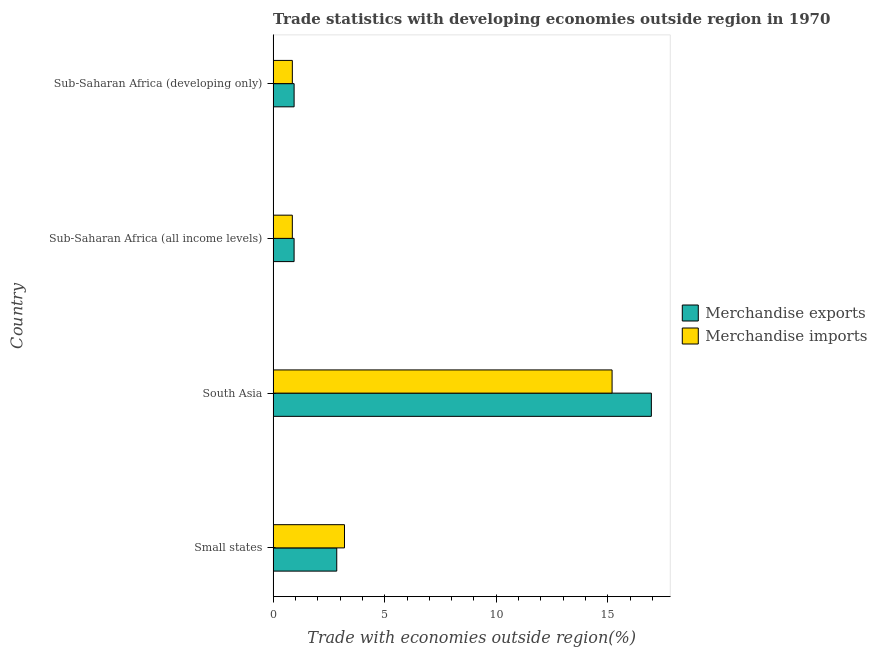How many different coloured bars are there?
Your answer should be compact. 2. Are the number of bars per tick equal to the number of legend labels?
Your answer should be very brief. Yes. How many bars are there on the 2nd tick from the bottom?
Your response must be concise. 2. What is the label of the 3rd group of bars from the top?
Your response must be concise. South Asia. In how many cases, is the number of bars for a given country not equal to the number of legend labels?
Provide a succinct answer. 0. What is the merchandise imports in South Asia?
Your response must be concise. 15.19. Across all countries, what is the maximum merchandise imports?
Provide a short and direct response. 15.19. Across all countries, what is the minimum merchandise exports?
Make the answer very short. 0.94. In which country was the merchandise imports minimum?
Your answer should be compact. Sub-Saharan Africa (all income levels). What is the total merchandise exports in the graph?
Make the answer very short. 21.68. What is the difference between the merchandise imports in Sub-Saharan Africa (all income levels) and that in Sub-Saharan Africa (developing only)?
Your answer should be compact. -0. What is the difference between the merchandise exports in South Asia and the merchandise imports in Sub-Saharan Africa (developing only)?
Ensure brevity in your answer.  16.09. What is the average merchandise imports per country?
Make the answer very short. 5.03. What is the difference between the merchandise exports and merchandise imports in Sub-Saharan Africa (developing only)?
Your answer should be compact. 0.08. In how many countries, is the merchandise exports greater than 9 %?
Offer a very short reply. 1. What is the ratio of the merchandise imports in Small states to that in South Asia?
Provide a short and direct response. 0.21. Is the merchandise exports in Small states less than that in Sub-Saharan Africa (developing only)?
Your response must be concise. No. Is the difference between the merchandise exports in Small states and Sub-Saharan Africa (all income levels) greater than the difference between the merchandise imports in Small states and Sub-Saharan Africa (all income levels)?
Offer a very short reply. No. What is the difference between the highest and the second highest merchandise imports?
Your answer should be compact. 11.99. What is the difference between the highest and the lowest merchandise imports?
Your answer should be compact. 14.33. Is the sum of the merchandise imports in Small states and South Asia greater than the maximum merchandise exports across all countries?
Your answer should be very brief. Yes. How many bars are there?
Your answer should be compact. 8. Are all the bars in the graph horizontal?
Offer a very short reply. Yes. How many countries are there in the graph?
Your response must be concise. 4. Does the graph contain any zero values?
Ensure brevity in your answer.  No. Does the graph contain grids?
Offer a very short reply. No. Where does the legend appear in the graph?
Your response must be concise. Center right. How many legend labels are there?
Provide a succinct answer. 2. What is the title of the graph?
Offer a terse response. Trade statistics with developing economies outside region in 1970. What is the label or title of the X-axis?
Your response must be concise. Trade with economies outside region(%). What is the label or title of the Y-axis?
Offer a terse response. Country. What is the Trade with economies outside region(%) of Merchandise exports in Small states?
Provide a succinct answer. 2.85. What is the Trade with economies outside region(%) of Merchandise imports in Small states?
Give a very brief answer. 3.2. What is the Trade with economies outside region(%) in Merchandise exports in South Asia?
Your answer should be compact. 16.95. What is the Trade with economies outside region(%) of Merchandise imports in South Asia?
Ensure brevity in your answer.  15.19. What is the Trade with economies outside region(%) of Merchandise exports in Sub-Saharan Africa (all income levels)?
Ensure brevity in your answer.  0.94. What is the Trade with economies outside region(%) of Merchandise imports in Sub-Saharan Africa (all income levels)?
Give a very brief answer. 0.86. What is the Trade with economies outside region(%) of Merchandise exports in Sub-Saharan Africa (developing only)?
Provide a succinct answer. 0.94. What is the Trade with economies outside region(%) in Merchandise imports in Sub-Saharan Africa (developing only)?
Keep it short and to the point. 0.86. Across all countries, what is the maximum Trade with economies outside region(%) in Merchandise exports?
Offer a terse response. 16.95. Across all countries, what is the maximum Trade with economies outside region(%) in Merchandise imports?
Give a very brief answer. 15.19. Across all countries, what is the minimum Trade with economies outside region(%) of Merchandise exports?
Ensure brevity in your answer.  0.94. Across all countries, what is the minimum Trade with economies outside region(%) in Merchandise imports?
Provide a succinct answer. 0.86. What is the total Trade with economies outside region(%) in Merchandise exports in the graph?
Keep it short and to the point. 21.68. What is the total Trade with economies outside region(%) in Merchandise imports in the graph?
Ensure brevity in your answer.  20.11. What is the difference between the Trade with economies outside region(%) of Merchandise exports in Small states and that in South Asia?
Give a very brief answer. -14.1. What is the difference between the Trade with economies outside region(%) in Merchandise imports in Small states and that in South Asia?
Your answer should be compact. -11.99. What is the difference between the Trade with economies outside region(%) in Merchandise exports in Small states and that in Sub-Saharan Africa (all income levels)?
Provide a short and direct response. 1.91. What is the difference between the Trade with economies outside region(%) in Merchandise imports in Small states and that in Sub-Saharan Africa (all income levels)?
Offer a terse response. 2.34. What is the difference between the Trade with economies outside region(%) of Merchandise exports in Small states and that in Sub-Saharan Africa (developing only)?
Provide a short and direct response. 1.91. What is the difference between the Trade with economies outside region(%) in Merchandise imports in Small states and that in Sub-Saharan Africa (developing only)?
Provide a short and direct response. 2.34. What is the difference between the Trade with economies outside region(%) of Merchandise exports in South Asia and that in Sub-Saharan Africa (all income levels)?
Provide a short and direct response. 16.01. What is the difference between the Trade with economies outside region(%) of Merchandise imports in South Asia and that in Sub-Saharan Africa (all income levels)?
Make the answer very short. 14.33. What is the difference between the Trade with economies outside region(%) of Merchandise exports in South Asia and that in Sub-Saharan Africa (developing only)?
Offer a terse response. 16.01. What is the difference between the Trade with economies outside region(%) in Merchandise imports in South Asia and that in Sub-Saharan Africa (developing only)?
Your answer should be very brief. 14.33. What is the difference between the Trade with economies outside region(%) in Merchandise exports in Sub-Saharan Africa (all income levels) and that in Sub-Saharan Africa (developing only)?
Your answer should be very brief. -0. What is the difference between the Trade with economies outside region(%) in Merchandise imports in Sub-Saharan Africa (all income levels) and that in Sub-Saharan Africa (developing only)?
Provide a short and direct response. -0. What is the difference between the Trade with economies outside region(%) in Merchandise exports in Small states and the Trade with economies outside region(%) in Merchandise imports in South Asia?
Keep it short and to the point. -12.34. What is the difference between the Trade with economies outside region(%) of Merchandise exports in Small states and the Trade with economies outside region(%) of Merchandise imports in Sub-Saharan Africa (all income levels)?
Offer a very short reply. 1.99. What is the difference between the Trade with economies outside region(%) of Merchandise exports in Small states and the Trade with economies outside region(%) of Merchandise imports in Sub-Saharan Africa (developing only)?
Your answer should be very brief. 1.99. What is the difference between the Trade with economies outside region(%) of Merchandise exports in South Asia and the Trade with economies outside region(%) of Merchandise imports in Sub-Saharan Africa (all income levels)?
Your answer should be very brief. 16.09. What is the difference between the Trade with economies outside region(%) of Merchandise exports in South Asia and the Trade with economies outside region(%) of Merchandise imports in Sub-Saharan Africa (developing only)?
Offer a very short reply. 16.09. What is the difference between the Trade with economies outside region(%) in Merchandise exports in Sub-Saharan Africa (all income levels) and the Trade with economies outside region(%) in Merchandise imports in Sub-Saharan Africa (developing only)?
Provide a succinct answer. 0.08. What is the average Trade with economies outside region(%) in Merchandise exports per country?
Your answer should be very brief. 5.42. What is the average Trade with economies outside region(%) of Merchandise imports per country?
Offer a very short reply. 5.03. What is the difference between the Trade with economies outside region(%) in Merchandise exports and Trade with economies outside region(%) in Merchandise imports in Small states?
Keep it short and to the point. -0.35. What is the difference between the Trade with economies outside region(%) in Merchandise exports and Trade with economies outside region(%) in Merchandise imports in South Asia?
Ensure brevity in your answer.  1.76. What is the difference between the Trade with economies outside region(%) in Merchandise exports and Trade with economies outside region(%) in Merchandise imports in Sub-Saharan Africa (all income levels)?
Your response must be concise. 0.08. What is the difference between the Trade with economies outside region(%) in Merchandise exports and Trade with economies outside region(%) in Merchandise imports in Sub-Saharan Africa (developing only)?
Provide a succinct answer. 0.08. What is the ratio of the Trade with economies outside region(%) of Merchandise exports in Small states to that in South Asia?
Your answer should be compact. 0.17. What is the ratio of the Trade with economies outside region(%) in Merchandise imports in Small states to that in South Asia?
Your response must be concise. 0.21. What is the ratio of the Trade with economies outside region(%) in Merchandise exports in Small states to that in Sub-Saharan Africa (all income levels)?
Provide a succinct answer. 3.03. What is the ratio of the Trade with economies outside region(%) in Merchandise imports in Small states to that in Sub-Saharan Africa (all income levels)?
Ensure brevity in your answer.  3.72. What is the ratio of the Trade with economies outside region(%) of Merchandise exports in Small states to that in Sub-Saharan Africa (developing only)?
Offer a very short reply. 3.03. What is the ratio of the Trade with economies outside region(%) in Merchandise imports in Small states to that in Sub-Saharan Africa (developing only)?
Your answer should be very brief. 3.71. What is the ratio of the Trade with economies outside region(%) of Merchandise exports in South Asia to that in Sub-Saharan Africa (all income levels)?
Your response must be concise. 18.03. What is the ratio of the Trade with economies outside region(%) of Merchandise imports in South Asia to that in Sub-Saharan Africa (all income levels)?
Ensure brevity in your answer.  17.65. What is the ratio of the Trade with economies outside region(%) in Merchandise exports in South Asia to that in Sub-Saharan Africa (developing only)?
Give a very brief answer. 18.03. What is the ratio of the Trade with economies outside region(%) in Merchandise imports in South Asia to that in Sub-Saharan Africa (developing only)?
Your answer should be compact. 17.63. What is the ratio of the Trade with economies outside region(%) of Merchandise exports in Sub-Saharan Africa (all income levels) to that in Sub-Saharan Africa (developing only)?
Your response must be concise. 1. What is the ratio of the Trade with economies outside region(%) of Merchandise imports in Sub-Saharan Africa (all income levels) to that in Sub-Saharan Africa (developing only)?
Give a very brief answer. 1. What is the difference between the highest and the second highest Trade with economies outside region(%) in Merchandise exports?
Provide a succinct answer. 14.1. What is the difference between the highest and the second highest Trade with economies outside region(%) of Merchandise imports?
Your response must be concise. 11.99. What is the difference between the highest and the lowest Trade with economies outside region(%) in Merchandise exports?
Keep it short and to the point. 16.01. What is the difference between the highest and the lowest Trade with economies outside region(%) in Merchandise imports?
Keep it short and to the point. 14.33. 